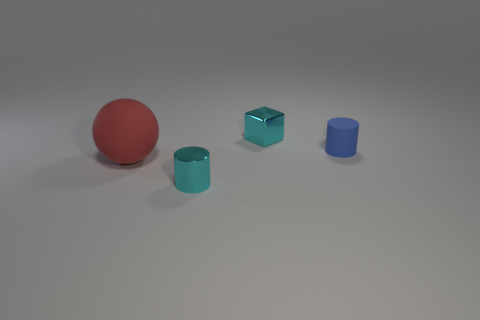Is there anything else that has the same size as the red ball?
Offer a very short reply. No. What number of other cylinders are the same size as the metallic cylinder?
Give a very brief answer. 1. What is the size of the cylinder that is behind the small shiny object in front of the red matte thing?
Make the answer very short. Small. There is a matte object that is on the right side of the cyan block; is its shape the same as the cyan thing that is left of the metallic block?
Your answer should be very brief. Yes. What color is the object that is both to the left of the tiny blue rubber cylinder and to the right of the small cyan metallic cylinder?
Provide a short and direct response. Cyan. Is there another small matte cylinder that has the same color as the small rubber cylinder?
Your answer should be compact. No. The cylinder in front of the large red ball is what color?
Your response must be concise. Cyan. Are there any rubber cylinders on the right side of the metallic object right of the small cyan shiny cylinder?
Offer a very short reply. Yes. Does the large object have the same color as the metal object left of the tiny cyan shiny cube?
Keep it short and to the point. No. Is there a big green object made of the same material as the large red sphere?
Your answer should be compact. No. 